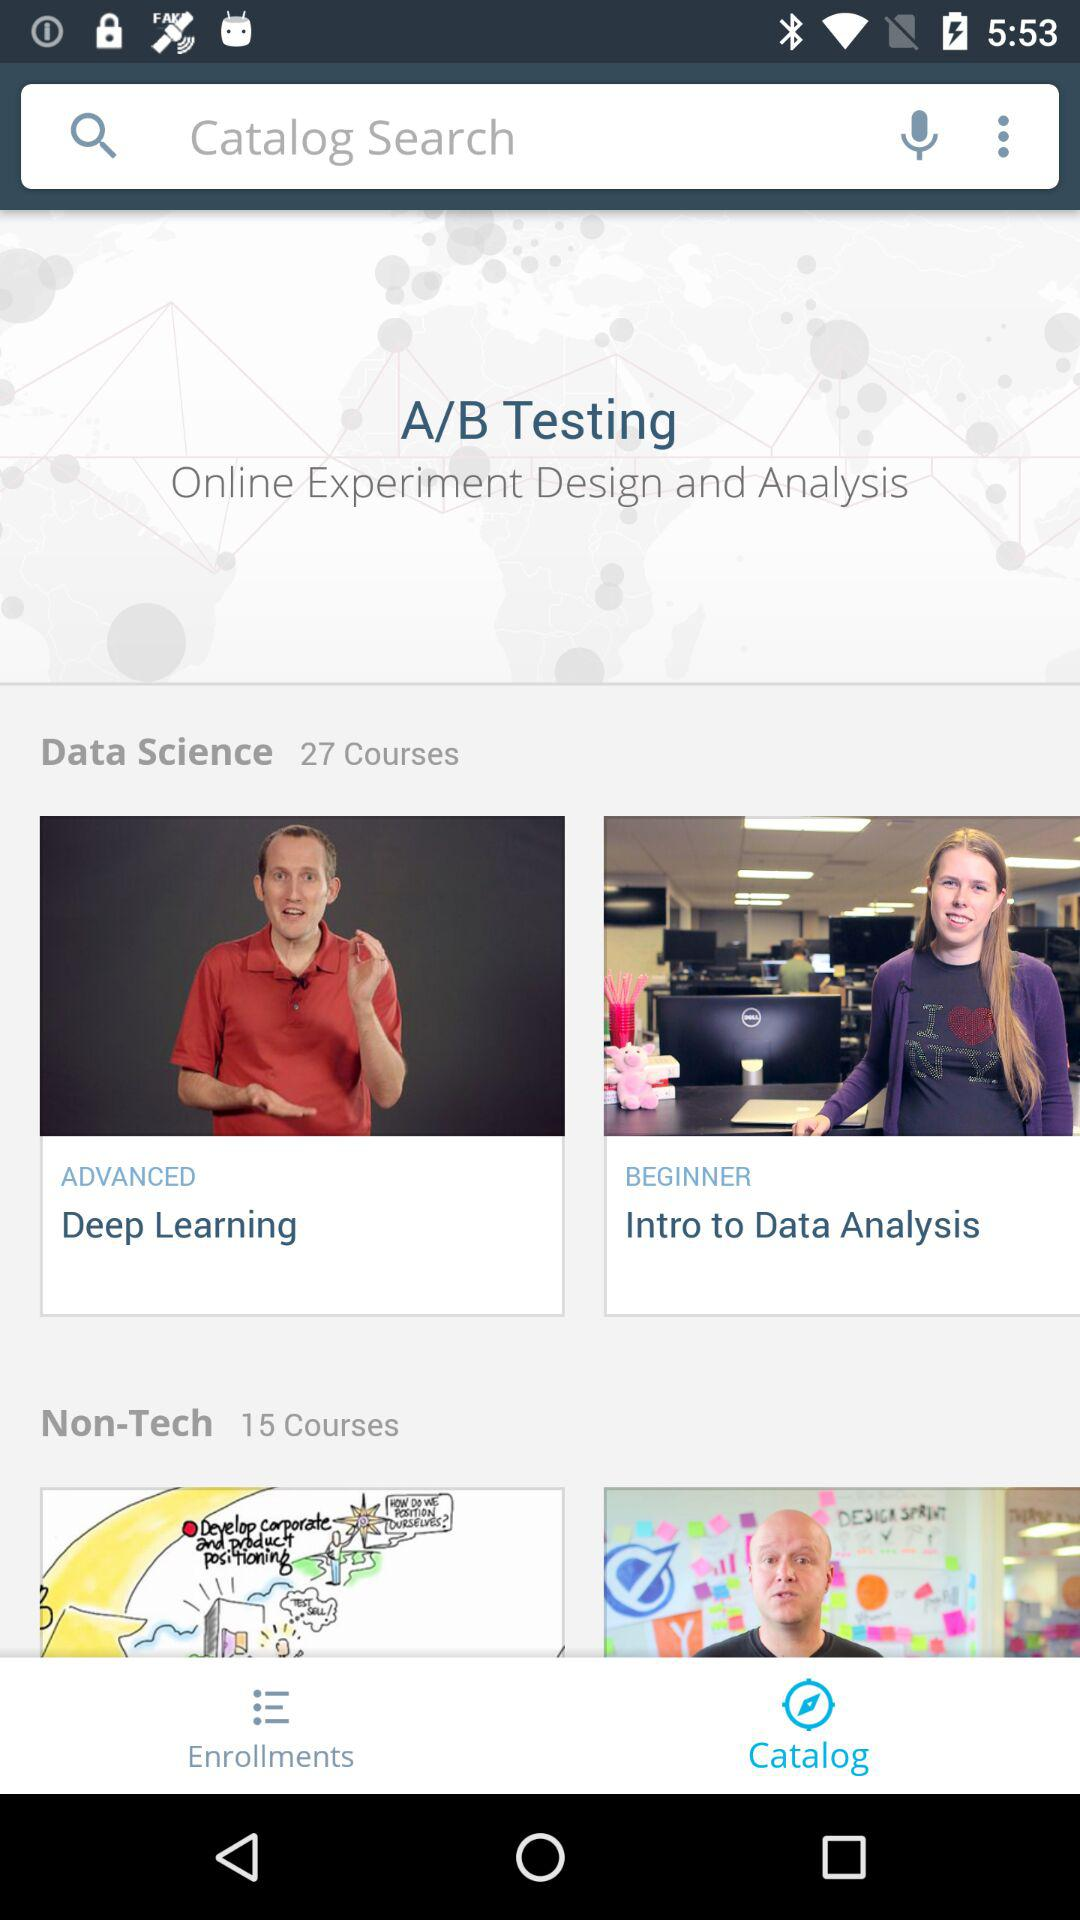Which tab is open? The opened tab is "Catalog". 